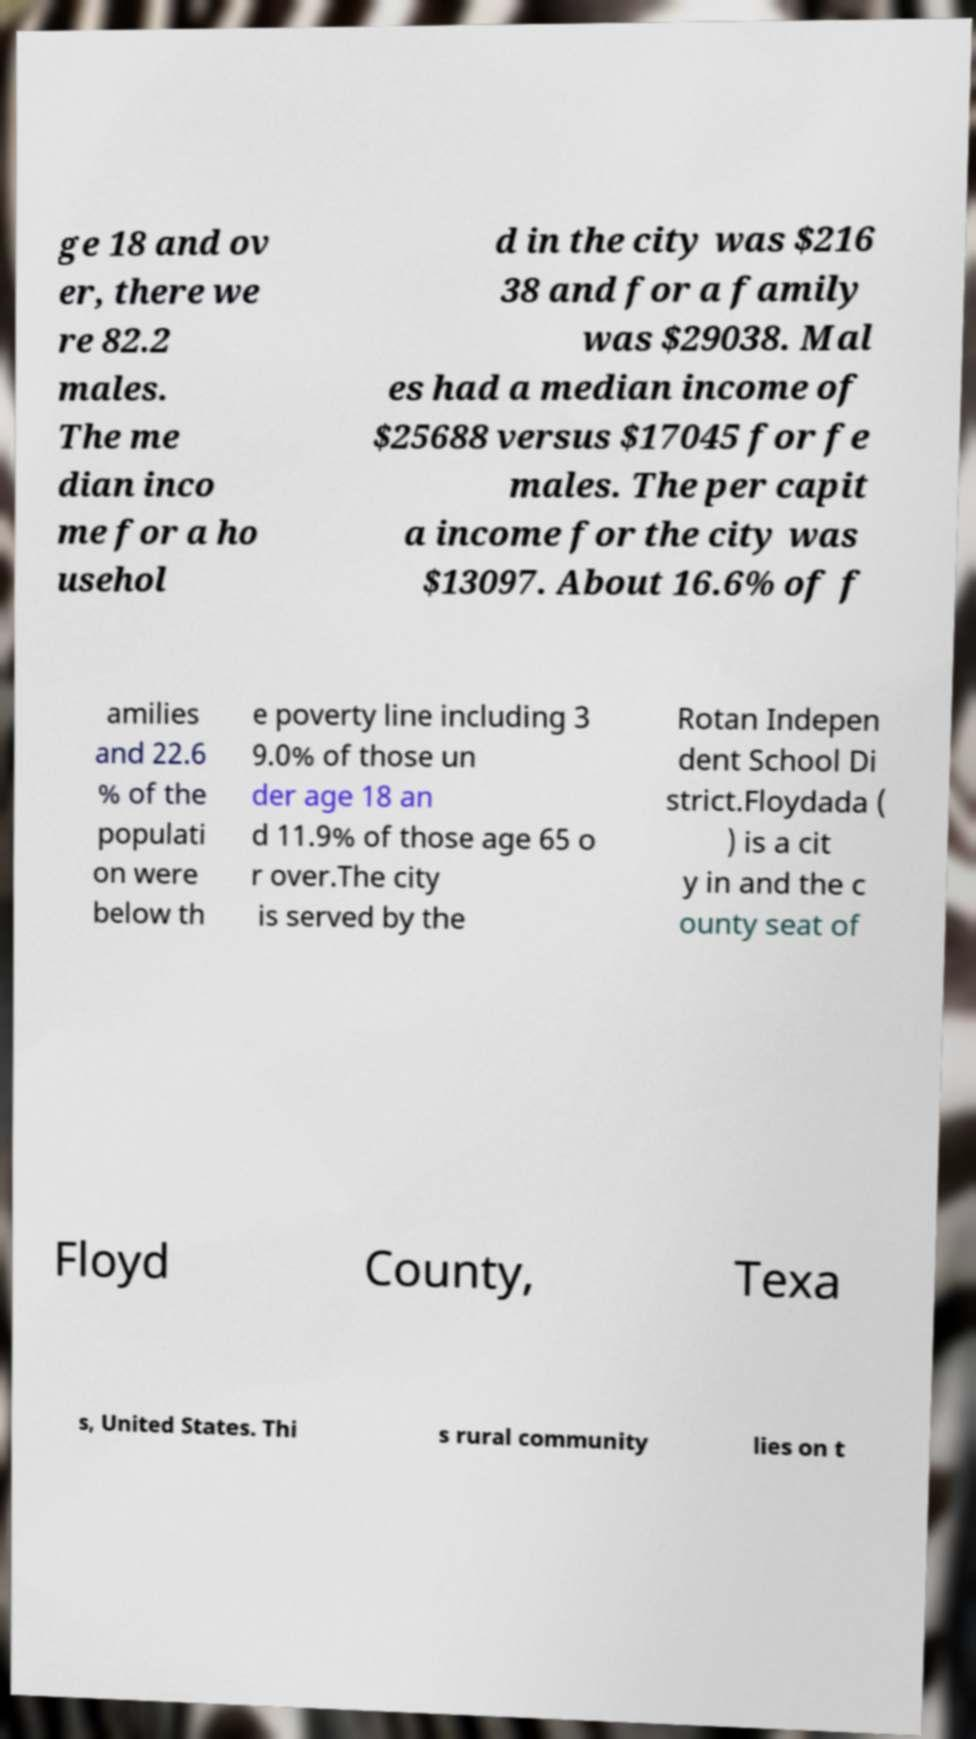Please identify and transcribe the text found in this image. ge 18 and ov er, there we re 82.2 males. The me dian inco me for a ho usehol d in the city was $216 38 and for a family was $29038. Mal es had a median income of $25688 versus $17045 for fe males. The per capit a income for the city was $13097. About 16.6% of f amilies and 22.6 % of the populati on were below th e poverty line including 3 9.0% of those un der age 18 an d 11.9% of those age 65 o r over.The city is served by the Rotan Indepen dent School Di strict.Floydada ( ) is a cit y in and the c ounty seat of Floyd County, Texa s, United States. Thi s rural community lies on t 